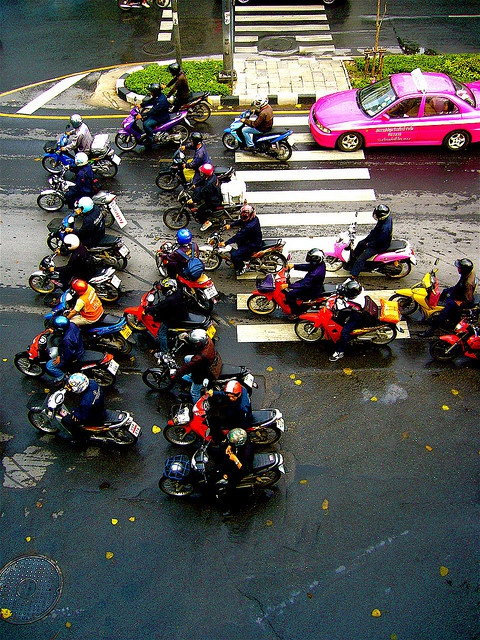Describe the objects in this image and their specific colors. I can see motorcycle in darkblue, black, white, gray, and olive tones, people in darkblue, black, navy, white, and gray tones, car in darkblue, lavender, violet, salmon, and black tones, motorcycle in darkblue, black, red, olive, and maroon tones, and motorcycle in darkblue, black, white, gray, and navy tones in this image. 